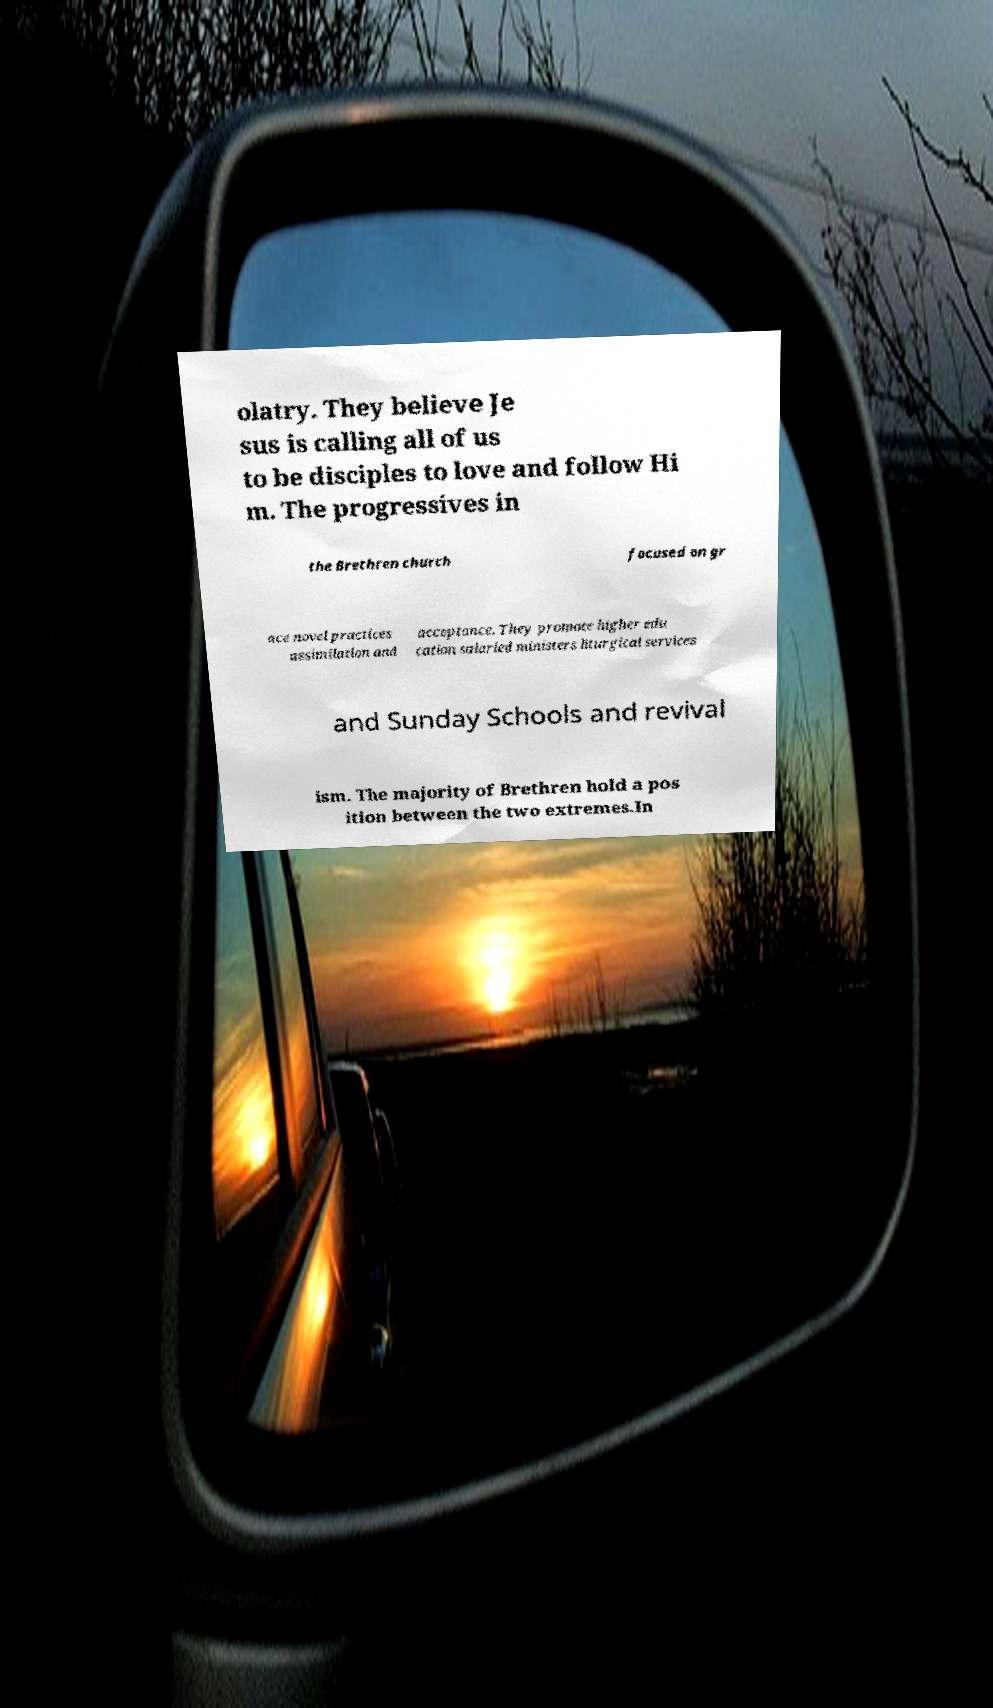There's text embedded in this image that I need extracted. Can you transcribe it verbatim? olatry. They believe Je sus is calling all of us to be disciples to love and follow Hi m. The progressives in the Brethren church focused on gr ace novel practices assimilation and acceptance. They promote higher edu cation salaried ministers liturgical services and Sunday Schools and revival ism. The majority of Brethren hold a pos ition between the two extremes.In 